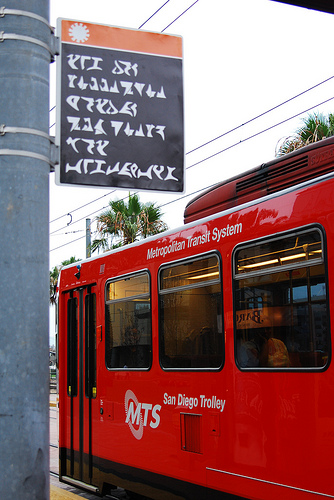<image>
Can you confirm if the pole is behind the trolley? No. The pole is not behind the trolley. From this viewpoint, the pole appears to be positioned elsewhere in the scene. 